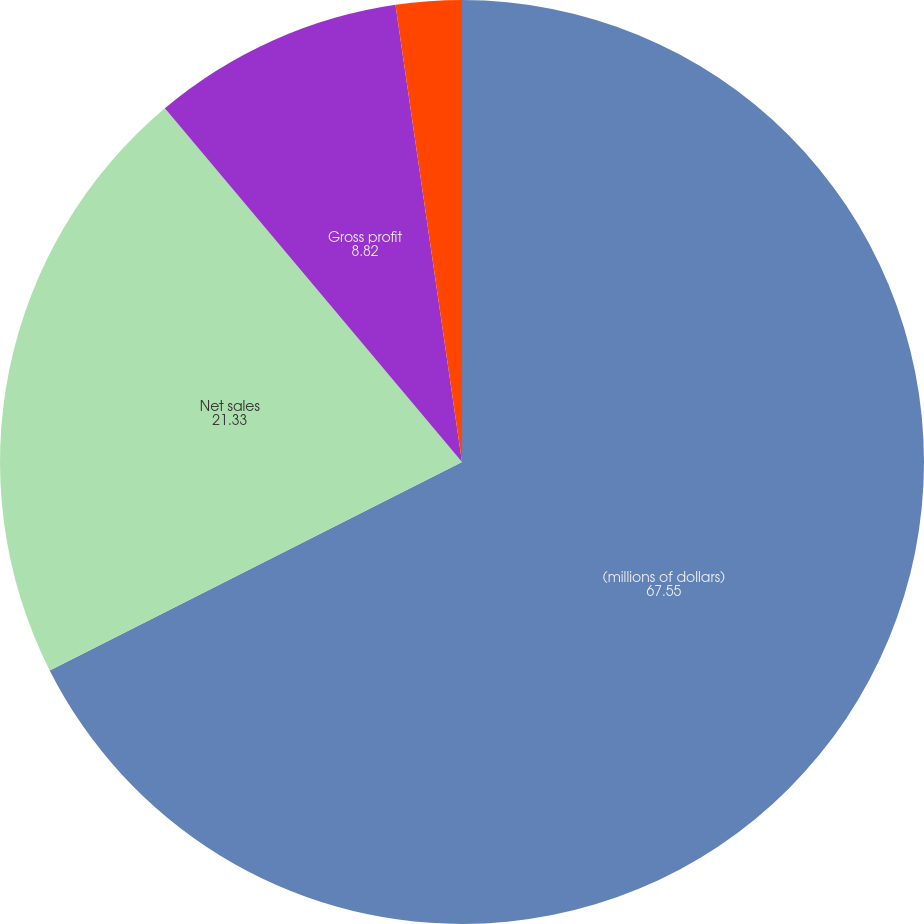Convert chart to OTSL. <chart><loc_0><loc_0><loc_500><loc_500><pie_chart><fcel>(millions of dollars)<fcel>Net sales<fcel>Gross profit<fcel>Net earnings<nl><fcel>67.55%<fcel>21.33%<fcel>8.82%<fcel>2.3%<nl></chart> 